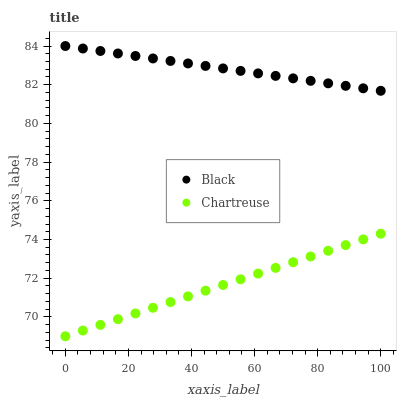Does Chartreuse have the minimum area under the curve?
Answer yes or no. Yes. Does Black have the maximum area under the curve?
Answer yes or no. Yes. Does Black have the minimum area under the curve?
Answer yes or no. No. Is Black the smoothest?
Answer yes or no. Yes. Is Chartreuse the roughest?
Answer yes or no. Yes. Is Black the roughest?
Answer yes or no. No. Does Chartreuse have the lowest value?
Answer yes or no. Yes. Does Black have the lowest value?
Answer yes or no. No. Does Black have the highest value?
Answer yes or no. Yes. Is Chartreuse less than Black?
Answer yes or no. Yes. Is Black greater than Chartreuse?
Answer yes or no. Yes. Does Chartreuse intersect Black?
Answer yes or no. No. 